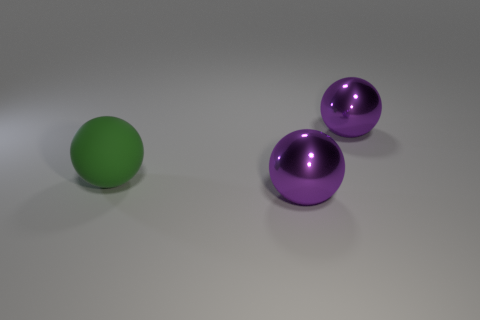What number of brown things are small cylinders or big rubber things? There are no brown objects present in the image; therefore, the count of brown things that are small cylinders or big rubber things is zero. 